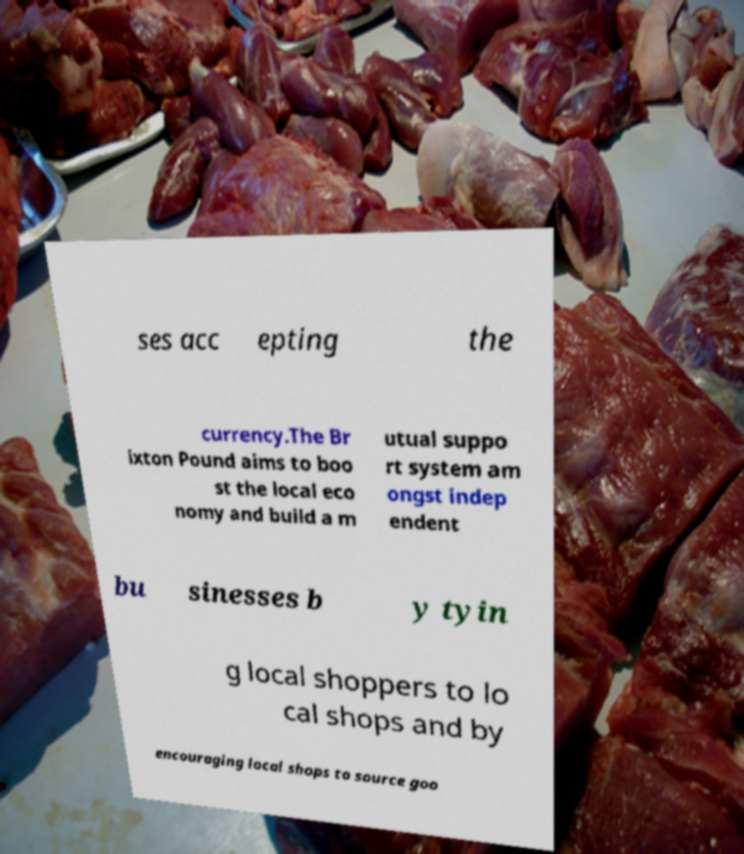Can you read and provide the text displayed in the image?This photo seems to have some interesting text. Can you extract and type it out for me? ses acc epting the currency.The Br ixton Pound aims to boo st the local eco nomy and build a m utual suppo rt system am ongst indep endent bu sinesses b y tyin g local shoppers to lo cal shops and by encouraging local shops to source goo 